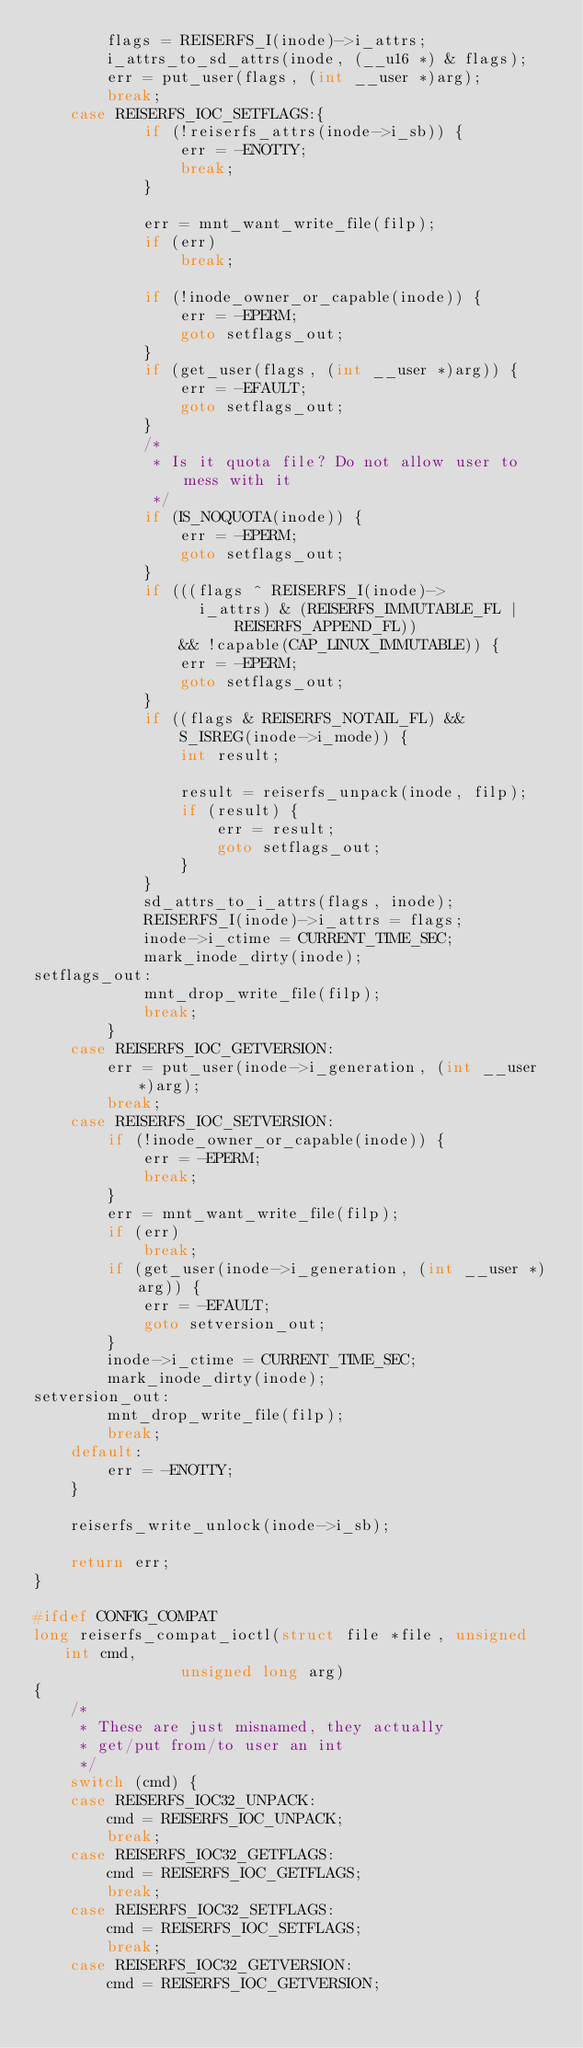<code> <loc_0><loc_0><loc_500><loc_500><_C_>		flags = REISERFS_I(inode)->i_attrs;
		i_attrs_to_sd_attrs(inode, (__u16 *) & flags);
		err = put_user(flags, (int __user *)arg);
		break;
	case REISERFS_IOC_SETFLAGS:{
			if (!reiserfs_attrs(inode->i_sb)) {
				err = -ENOTTY;
				break;
			}

			err = mnt_want_write_file(filp);
			if (err)
				break;

			if (!inode_owner_or_capable(inode)) {
				err = -EPERM;
				goto setflags_out;
			}
			if (get_user(flags, (int __user *)arg)) {
				err = -EFAULT;
				goto setflags_out;
			}
			/*
			 * Is it quota file? Do not allow user to mess with it
			 */
			if (IS_NOQUOTA(inode)) {
				err = -EPERM;
				goto setflags_out;
			}
			if (((flags ^ REISERFS_I(inode)->
			      i_attrs) & (REISERFS_IMMUTABLE_FL |
					  REISERFS_APPEND_FL))
			    && !capable(CAP_LINUX_IMMUTABLE)) {
				err = -EPERM;
				goto setflags_out;
			}
			if ((flags & REISERFS_NOTAIL_FL) &&
			    S_ISREG(inode->i_mode)) {
				int result;

				result = reiserfs_unpack(inode, filp);
				if (result) {
					err = result;
					goto setflags_out;
				}
			}
			sd_attrs_to_i_attrs(flags, inode);
			REISERFS_I(inode)->i_attrs = flags;
			inode->i_ctime = CURRENT_TIME_SEC;
			mark_inode_dirty(inode);
setflags_out:
			mnt_drop_write_file(filp);
			break;
		}
	case REISERFS_IOC_GETVERSION:
		err = put_user(inode->i_generation, (int __user *)arg);
		break;
	case REISERFS_IOC_SETVERSION:
		if (!inode_owner_or_capable(inode)) {
			err = -EPERM;
			break;
		}
		err = mnt_want_write_file(filp);
		if (err)
			break;
		if (get_user(inode->i_generation, (int __user *)arg)) {
			err = -EFAULT;
			goto setversion_out;
		}
		inode->i_ctime = CURRENT_TIME_SEC;
		mark_inode_dirty(inode);
setversion_out:
		mnt_drop_write_file(filp);
		break;
	default:
		err = -ENOTTY;
	}

	reiserfs_write_unlock(inode->i_sb);

	return err;
}

#ifdef CONFIG_COMPAT
long reiserfs_compat_ioctl(struct file *file, unsigned int cmd,
				unsigned long arg)
{
	/*
	 * These are just misnamed, they actually
	 * get/put from/to user an int
	 */
	switch (cmd) {
	case REISERFS_IOC32_UNPACK:
		cmd = REISERFS_IOC_UNPACK;
		break;
	case REISERFS_IOC32_GETFLAGS:
		cmd = REISERFS_IOC_GETFLAGS;
		break;
	case REISERFS_IOC32_SETFLAGS:
		cmd = REISERFS_IOC_SETFLAGS;
		break;
	case REISERFS_IOC32_GETVERSION:
		cmd = REISERFS_IOC_GETVERSION;</code> 